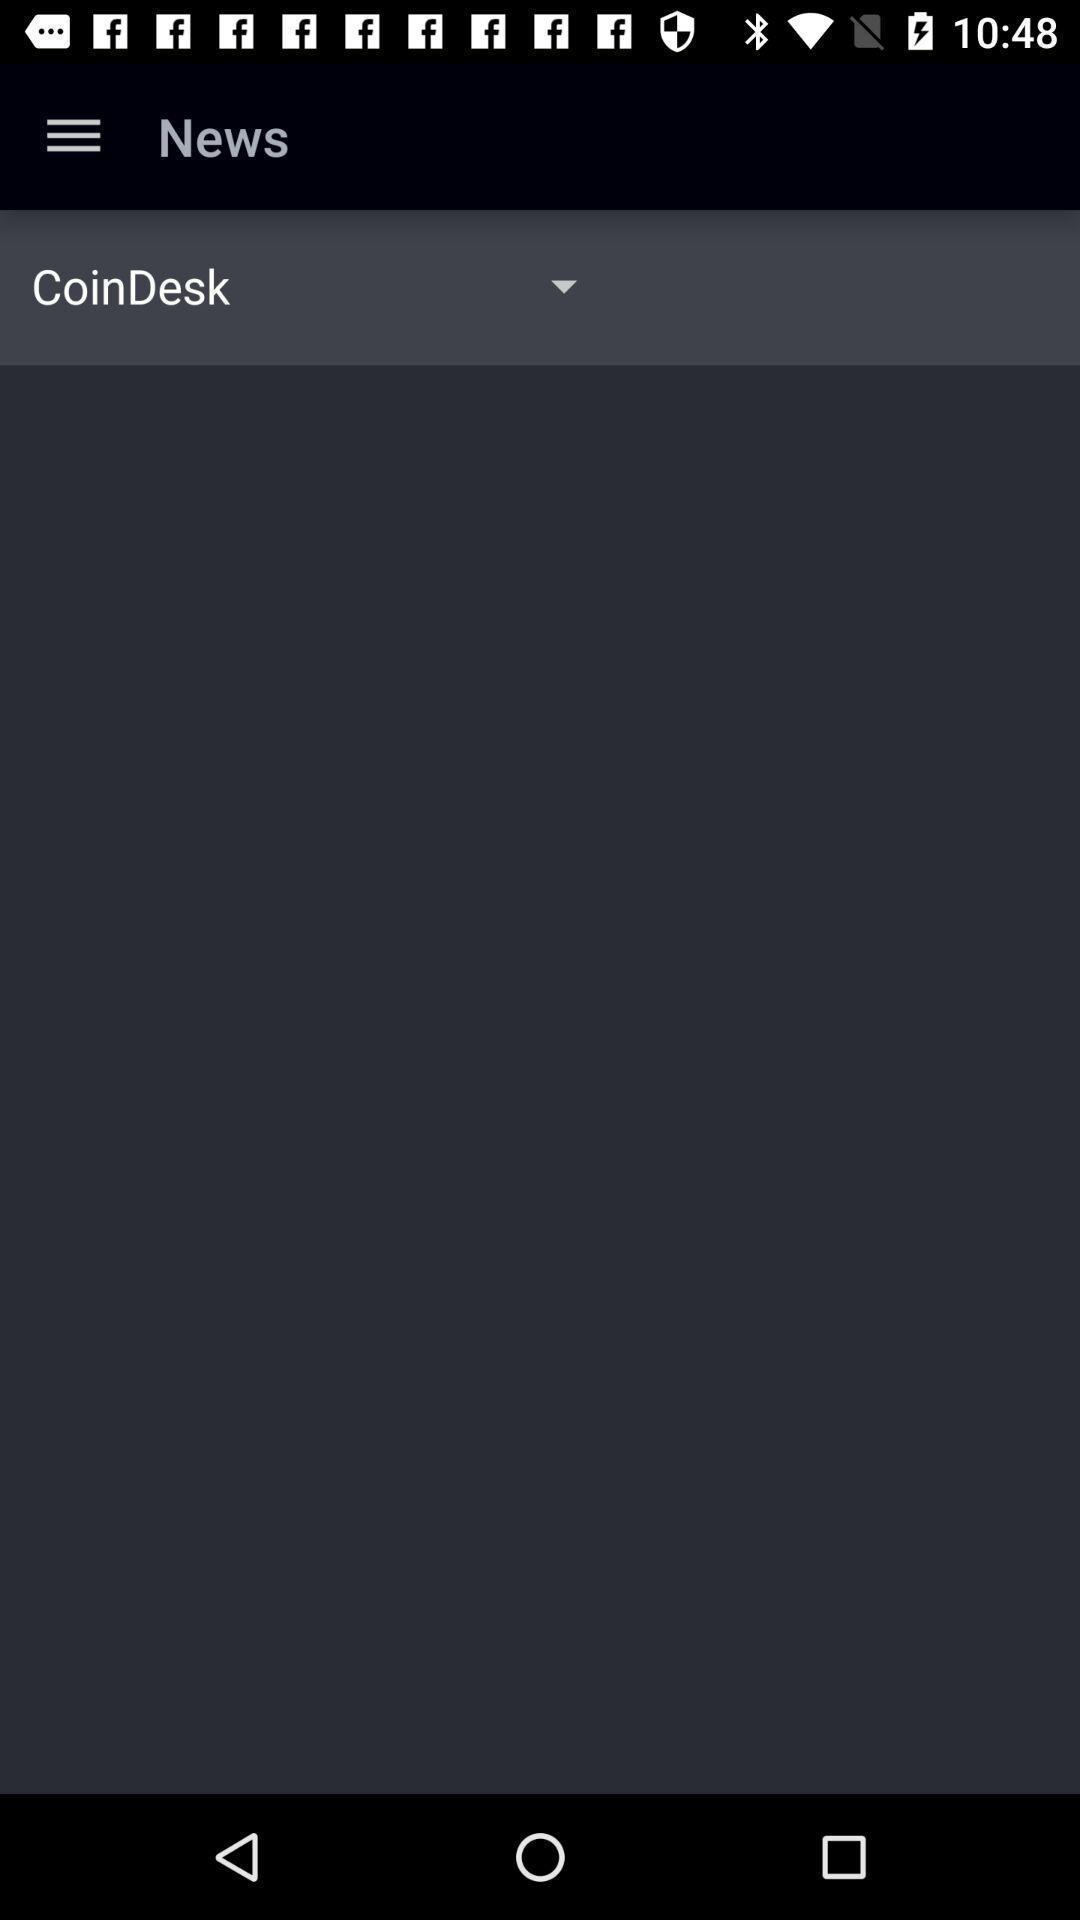Provide a textual representation of this image. Page displaying with no results for news feed. 